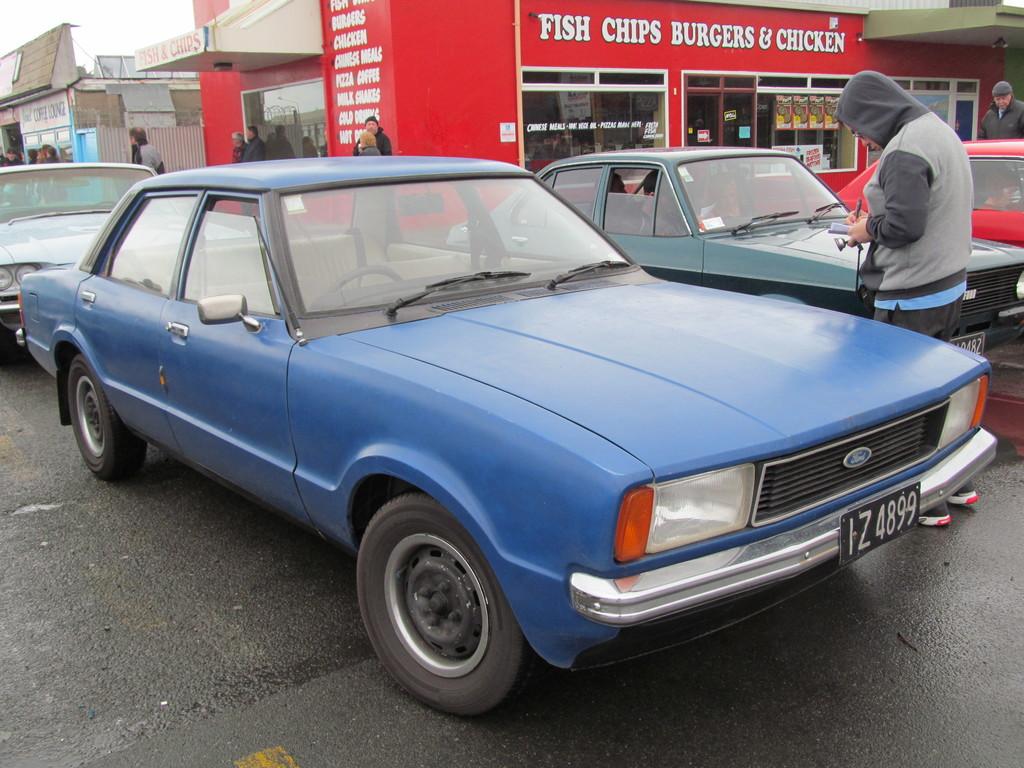What foods does the restaurant serve?
Offer a very short reply. Fish chips burgers & chicken. What is the license plate number?
Provide a short and direct response. Iz4899. 